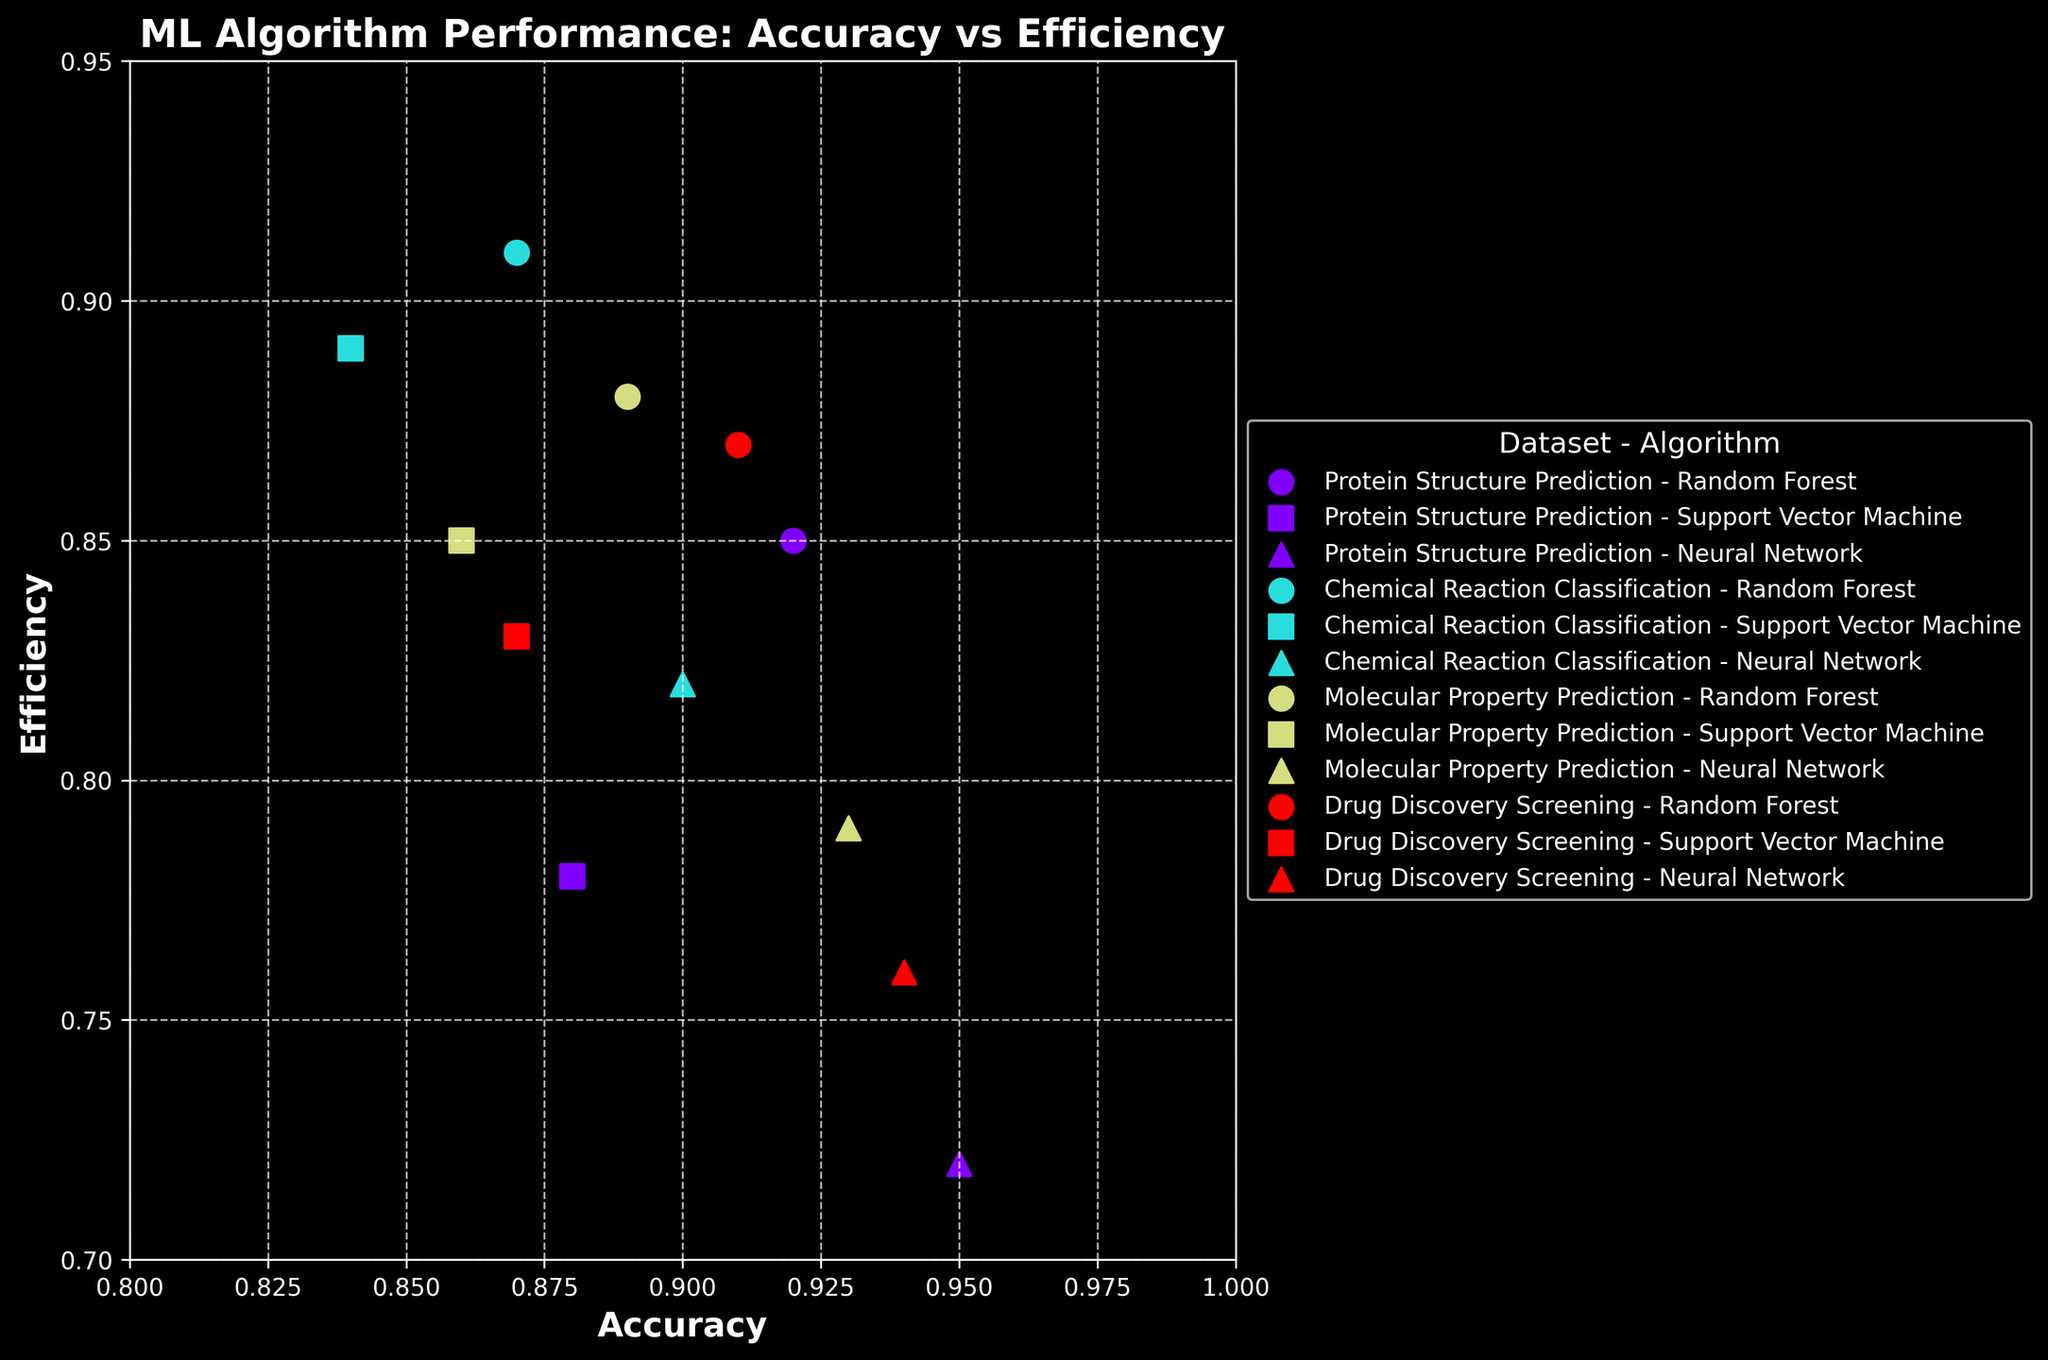How many machine learning algorithms are compared in the plot? The plot shows different markers for each algorithm across multiple datasets. By observing the legend, we can count the different algorithms.
Answer: 3 What is the maximum accuracy observed in the figure? By looking at the x-axis, we can identify the data point that is farthest to the right. This corresponds to the maximum accuracy value.
Answer: 0.95 Which dataset has the highest efficiency for the Neural Network algorithm? The Neural Network's efficiency for each dataset can be found by locating the data points with the triangle marker and observing their y-axis values.
Answer: Chemical Reaction Classification Between Random Forest and Support Vector Machine, which algorithm shows better efficiency for Drug Discovery Screening? For Drug Discovery Screening, compare the efficiency values on the y-axis for the Random Forest and Support Vector Machine points.
Answer: Random Forest On which dataset does the Random Forest attain the highest accuracy? The Random Forest's accuracy for each dataset can be found by locating the data points with the circle marker and comparing their x-axis positions.
Answer: Protein Structure Prediction What is the difference in efficiency between the Neural Network and Support Vector Machine for Protein Structure Prediction? For Protein Structure Prediction, find the y-axis values of the data points for both Neural Network and Support Vector Machine and calculate their difference.
Answer: 0.06 Which machine learning algorithm generally has the highest accuracy across all datasets? To determine the algorithm with the highest overall accuracy, compare the x-axis values of the points for each algorithm across all datasets.
Answer: Neural Network Is there any dataset where Support Vector Machine is more efficient than Random Forest? Check the y-axis values for Support Vector Machine and Random Forest points for each dataset to see if Support Vector Machine has a higher efficiency value in any case.
Answer: Yes, Chemical Reaction Classification How does Neural Network's efficiency trend across the datasets compared to Random Forest's? By observing the y-axis values of Neural Network and Random Forest's efficiency across all datasets, we can analyze if there is an increasing or decreasing trend for efficiency.
Answer: Neural Network's efficiency generally decreases Which dataset-algorithm combination achieves an accuracy of exactly 0.87? Locate the data point on the x-axis at 0.87 and check the corresponding dataset-algorithm combination by referring to the legend and colors/markers used.
Answer: Random Forest on Chemical Reaction Classification 